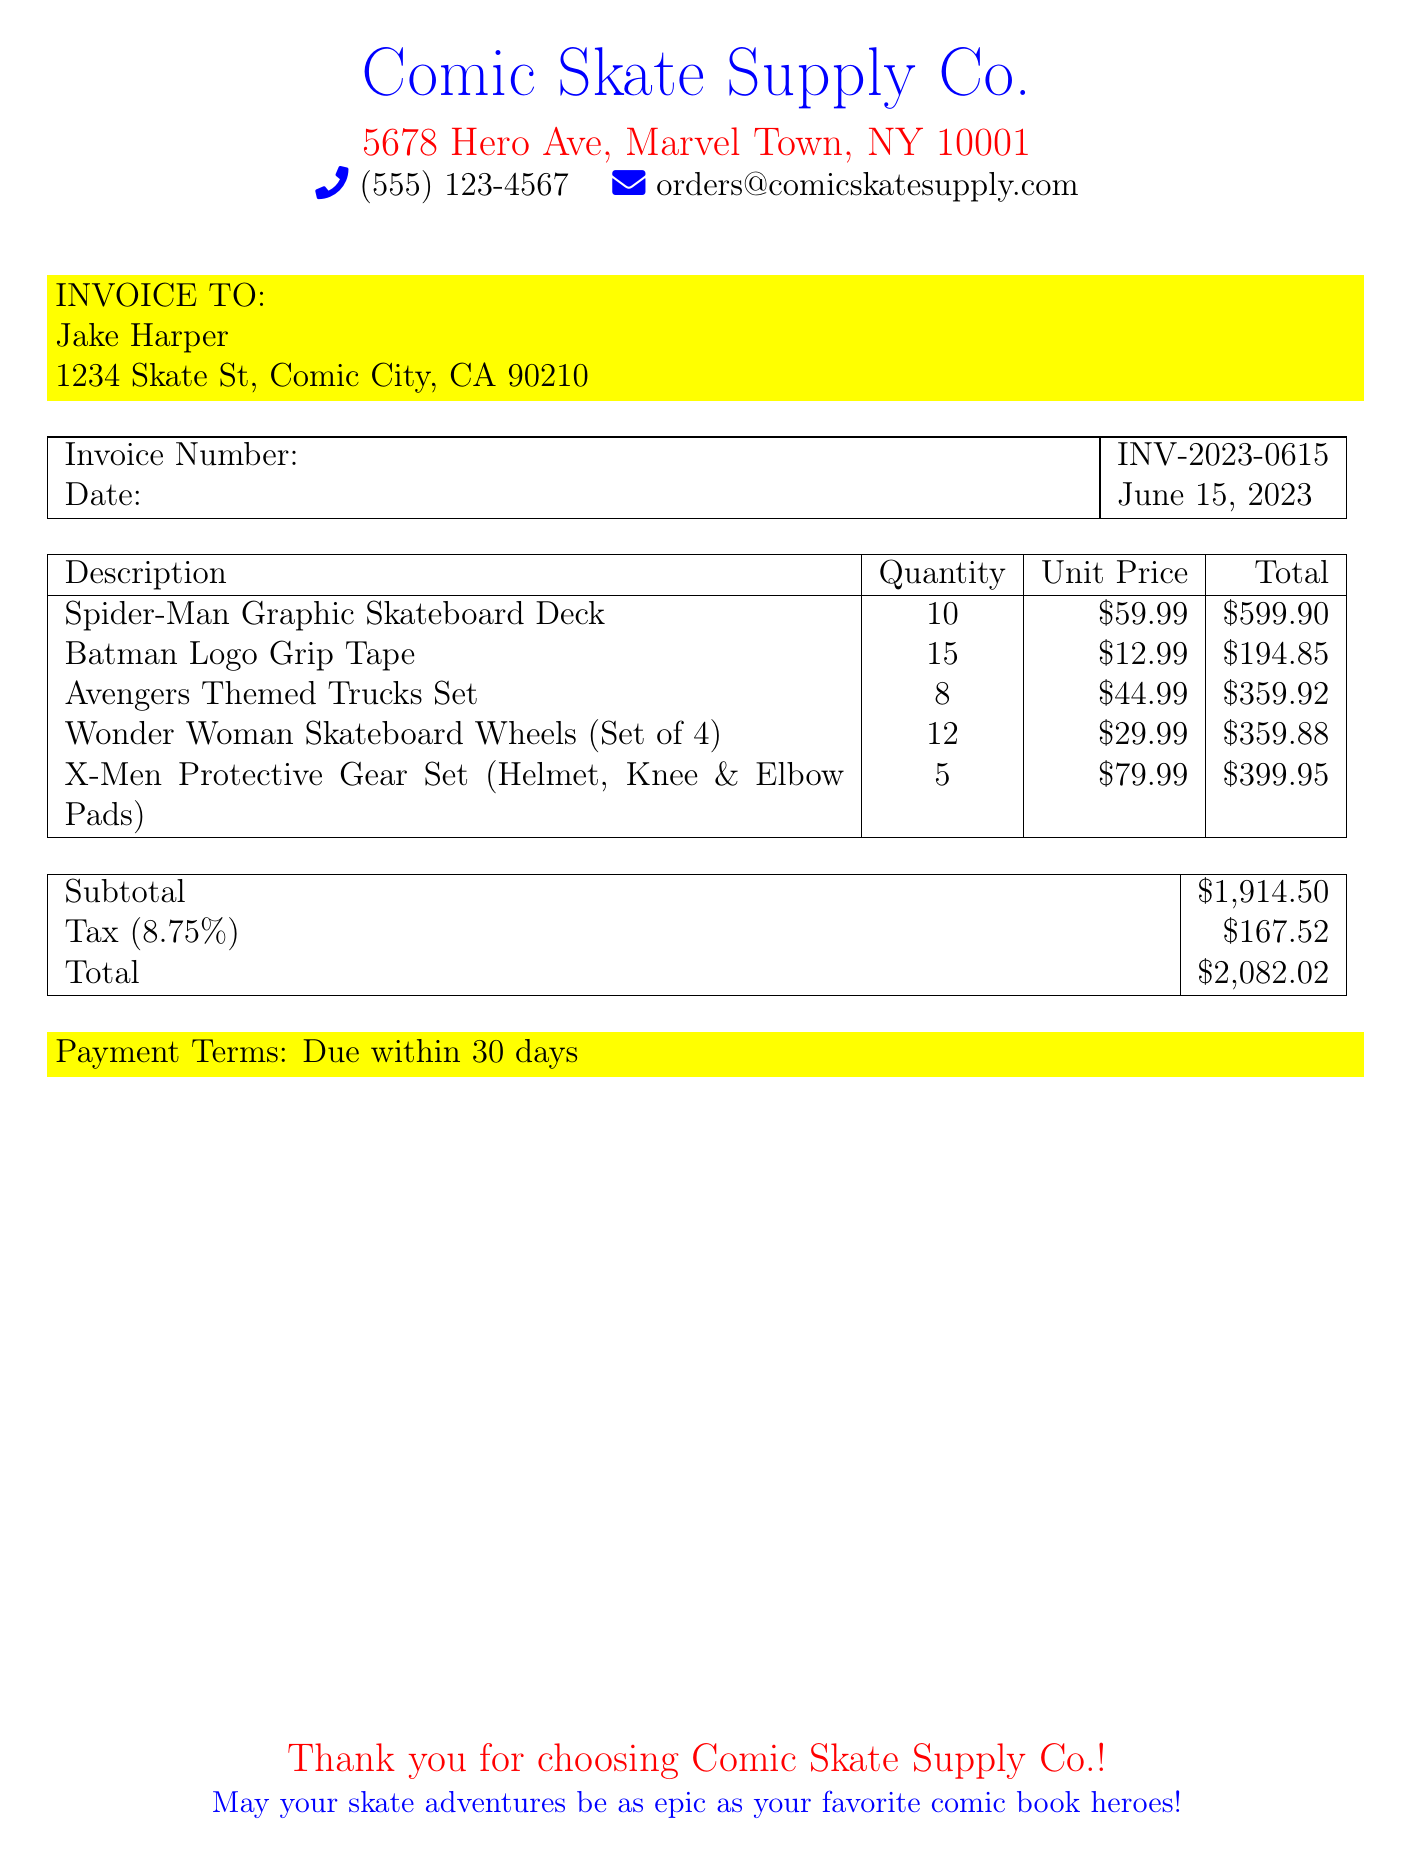What is the invoice number? The invoice number is listed in the document for reference tracking, specifically as INV-2023-0615.
Answer: INV-2023-0615 What is the total amount due? The total amount due is the final figure at the end of the invoice, which sums the subtotal and tax.
Answer: $2,082.02 How many Spider-Man graphic skateboards were ordered? The document specifies the quantity ordered for each item, with Spider-Man being 10.
Answer: 10 What is the unit price of Batman Logo Grip Tape? The unit price is detailed next to each item, showing Batman Logo Grip Tape's price as $12.99.
Answer: $12.99 What is the subtotal before tax? The subtotal is the amount before tax is applied, listed as $1,914.50.
Answer: $1,914.50 How many different types of skate gear are listed on the invoice? The document lists multiple items, which can be counted for a total. There are 5 different types of skate gear.
Answer: 5 What is the tax rate applied to the invoice? The tax rate is mentioned in the document, specifically stated as 8.75%.
Answer: 8.75% Who is the invoice addressed to? The invoice is addressed to a specific individual, which is detailed at the beginning of the invoice.
Answer: Jake Harper What is the payment term specified in the document? The document outlines the payment term, indicating when payment is expected.
Answer: Due within 30 days 